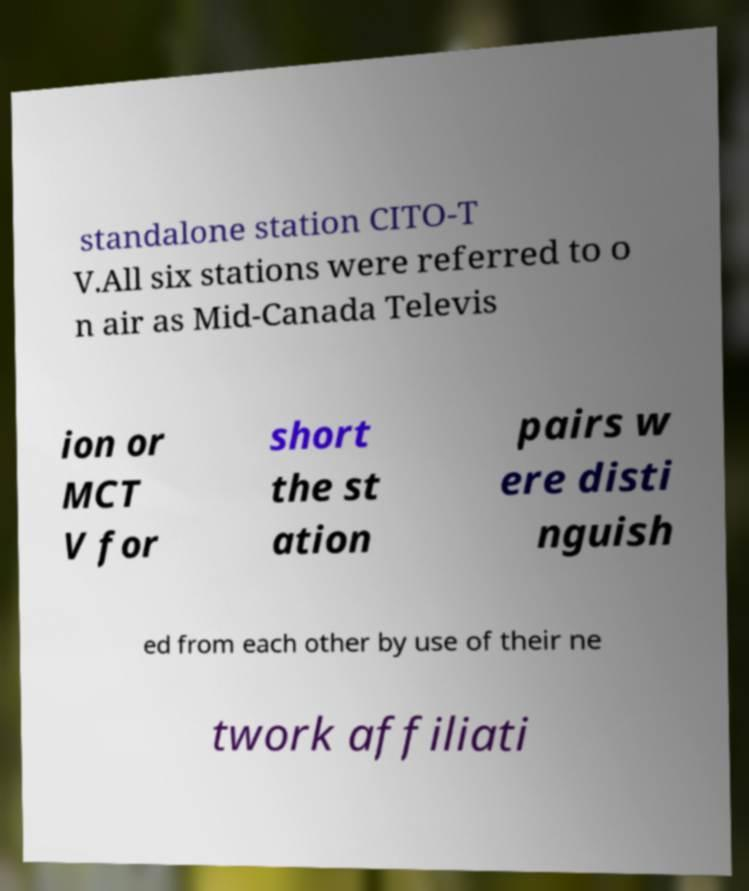What messages or text are displayed in this image? I need them in a readable, typed format. standalone station CITO-T V.All six stations were referred to o n air as Mid-Canada Televis ion or MCT V for short the st ation pairs w ere disti nguish ed from each other by use of their ne twork affiliati 